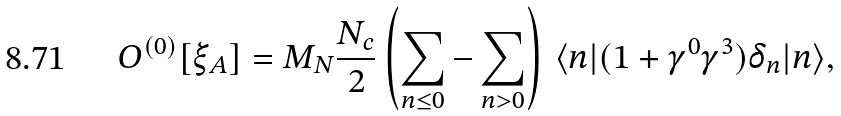Convert formula to latex. <formula><loc_0><loc_0><loc_500><loc_500>O ^ { ( 0 ) } [ \xi _ { A } ] = M _ { N } \frac { N _ { c } } { 2 } \left ( \sum _ { n \leq 0 } - \sum _ { n > 0 } \right ) \, \langle n | ( 1 + \gamma ^ { 0 } \gamma ^ { 3 } ) \delta _ { n } | n \rangle ,</formula> 